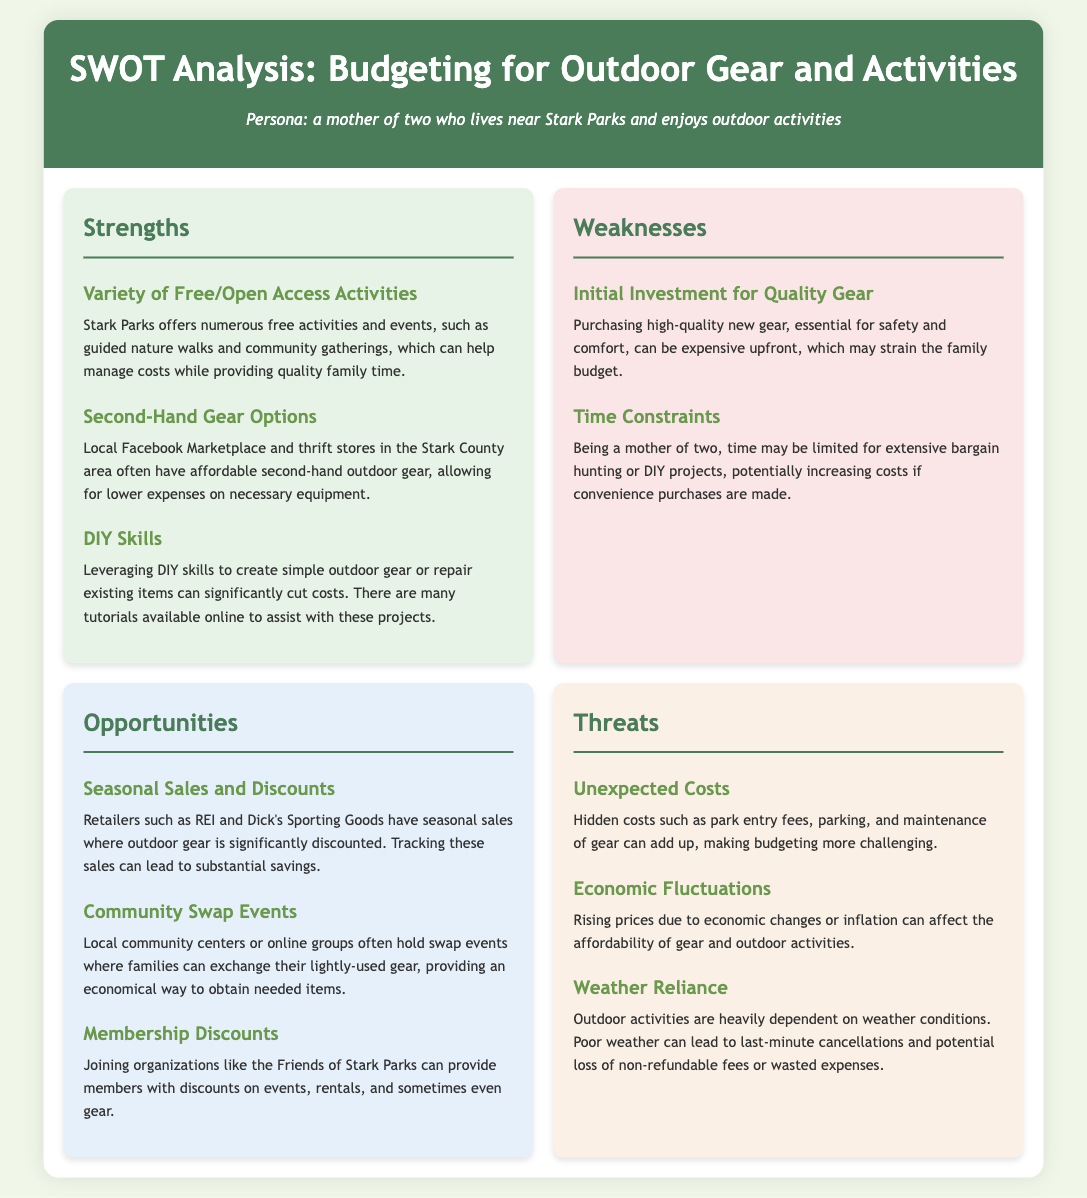what is one of the strengths mentioned in the analysis? One of the strengths listed is that Stark Parks offers a variety of free activities, which can help manage costs.
Answer: Variety of Free/Open Access Activities what is a weakness related to budgeting for outdoor gear? The document states that the initial investment for quality gear can be expensive, straining the family budget.
Answer: Initial Investment for Quality Gear how can membership help with budgeting? The analysis mentions that joining organizations can provide discounts, helping to lower costs.
Answer: Membership Discounts what opportunity is available for obtaining outdoor gear economically? The document highlights community swap events as a way to exchange lightly-used gear, which can help save money.
Answer: Community Swap Events what is a potential unexpected cost mentioned? The SWOT analysis includes park entry fees as one of the hidden costs that can affect budgeting.
Answer: Unexpected Costs what economic factor is identified as a threat? The document notes that economic fluctuations can affect the affordability of outdoor gear and activities.
Answer: Economic Fluctuations how can DIY skills impact budgeting for outdoor activities? The analysis states that leveraging DIY skills can significantly cut costs related to outdoor gear.
Answer: DIY Skills what type of sales can help save money on outdoor gear? Seasonal sales and discounts from various retailers are pointed out as opportunities for savings.
Answer: Seasonal Sales and Discounts 